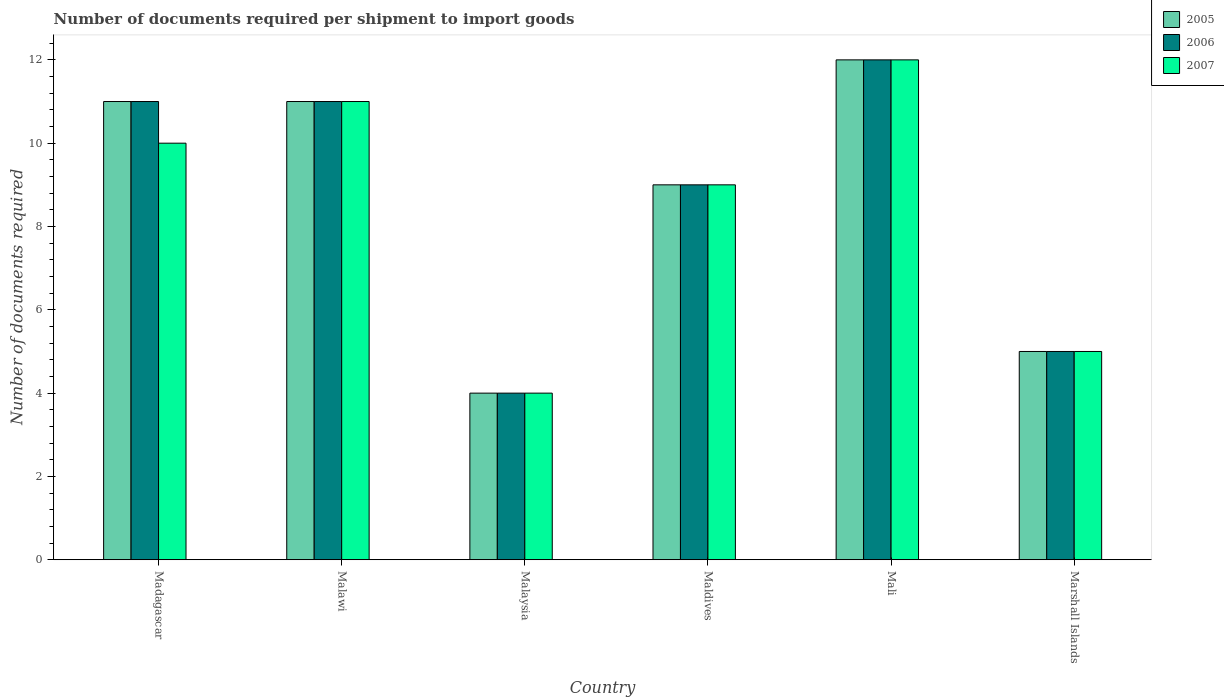How many bars are there on the 3rd tick from the left?
Your answer should be very brief. 3. How many bars are there on the 5th tick from the right?
Give a very brief answer. 3. What is the label of the 4th group of bars from the left?
Offer a very short reply. Maldives. In how many cases, is the number of bars for a given country not equal to the number of legend labels?
Your answer should be very brief. 0. What is the number of documents required per shipment to import goods in 2006 in Maldives?
Make the answer very short. 9. Across all countries, what is the maximum number of documents required per shipment to import goods in 2007?
Ensure brevity in your answer.  12. Across all countries, what is the minimum number of documents required per shipment to import goods in 2007?
Provide a succinct answer. 4. In which country was the number of documents required per shipment to import goods in 2007 maximum?
Provide a succinct answer. Mali. In which country was the number of documents required per shipment to import goods in 2007 minimum?
Your answer should be very brief. Malaysia. What is the total number of documents required per shipment to import goods in 2006 in the graph?
Offer a terse response. 52. What is the difference between the number of documents required per shipment to import goods in 2006 in Marshall Islands and the number of documents required per shipment to import goods in 2007 in Madagascar?
Ensure brevity in your answer.  -5. What is the average number of documents required per shipment to import goods in 2005 per country?
Offer a terse response. 8.67. What is the difference between the number of documents required per shipment to import goods of/in 2007 and number of documents required per shipment to import goods of/in 2005 in Mali?
Offer a very short reply. 0. In how many countries, is the number of documents required per shipment to import goods in 2007 greater than 10?
Keep it short and to the point. 2. What is the ratio of the number of documents required per shipment to import goods in 2006 in Malaysia to that in Maldives?
Give a very brief answer. 0.44. Is the number of documents required per shipment to import goods in 2007 in Malawi less than that in Marshall Islands?
Ensure brevity in your answer.  No. Is the difference between the number of documents required per shipment to import goods in 2007 in Malawi and Malaysia greater than the difference between the number of documents required per shipment to import goods in 2005 in Malawi and Malaysia?
Ensure brevity in your answer.  No. What is the difference between the highest and the second highest number of documents required per shipment to import goods in 2005?
Offer a terse response. -1. In how many countries, is the number of documents required per shipment to import goods in 2006 greater than the average number of documents required per shipment to import goods in 2006 taken over all countries?
Your response must be concise. 4. Is the sum of the number of documents required per shipment to import goods in 2006 in Malaysia and Mali greater than the maximum number of documents required per shipment to import goods in 2007 across all countries?
Make the answer very short. Yes. What does the 1st bar from the right in Mali represents?
Offer a very short reply. 2007. Is it the case that in every country, the sum of the number of documents required per shipment to import goods in 2005 and number of documents required per shipment to import goods in 2006 is greater than the number of documents required per shipment to import goods in 2007?
Make the answer very short. Yes. How many countries are there in the graph?
Your answer should be compact. 6. What is the difference between two consecutive major ticks on the Y-axis?
Provide a short and direct response. 2. Are the values on the major ticks of Y-axis written in scientific E-notation?
Provide a short and direct response. No. Does the graph contain grids?
Offer a very short reply. No. Where does the legend appear in the graph?
Your answer should be very brief. Top right. How are the legend labels stacked?
Ensure brevity in your answer.  Vertical. What is the title of the graph?
Your answer should be compact. Number of documents required per shipment to import goods. What is the label or title of the X-axis?
Provide a short and direct response. Country. What is the label or title of the Y-axis?
Your answer should be very brief. Number of documents required. What is the Number of documents required in 2006 in Madagascar?
Offer a terse response. 11. What is the Number of documents required of 2005 in Malawi?
Offer a terse response. 11. What is the Number of documents required in 2007 in Malawi?
Offer a terse response. 11. What is the Number of documents required in 2006 in Malaysia?
Your answer should be compact. 4. What is the Number of documents required of 2007 in Malaysia?
Give a very brief answer. 4. What is the Number of documents required of 2006 in Maldives?
Provide a short and direct response. 9. What is the Number of documents required in 2007 in Maldives?
Your response must be concise. 9. What is the Number of documents required of 2006 in Mali?
Offer a very short reply. 12. What is the Number of documents required of 2007 in Mali?
Give a very brief answer. 12. What is the Number of documents required in 2005 in Marshall Islands?
Keep it short and to the point. 5. What is the Number of documents required of 2007 in Marshall Islands?
Provide a short and direct response. 5. Across all countries, what is the maximum Number of documents required of 2007?
Ensure brevity in your answer.  12. What is the total Number of documents required of 2006 in the graph?
Provide a succinct answer. 52. What is the total Number of documents required in 2007 in the graph?
Offer a terse response. 51. What is the difference between the Number of documents required in 2007 in Madagascar and that in Malawi?
Keep it short and to the point. -1. What is the difference between the Number of documents required in 2006 in Madagascar and that in Maldives?
Your answer should be very brief. 2. What is the difference between the Number of documents required of 2007 in Madagascar and that in Maldives?
Offer a terse response. 1. What is the difference between the Number of documents required in 2006 in Madagascar and that in Mali?
Give a very brief answer. -1. What is the difference between the Number of documents required in 2005 in Madagascar and that in Marshall Islands?
Keep it short and to the point. 6. What is the difference between the Number of documents required of 2005 in Malawi and that in Malaysia?
Keep it short and to the point. 7. What is the difference between the Number of documents required of 2007 in Malawi and that in Malaysia?
Provide a short and direct response. 7. What is the difference between the Number of documents required in 2006 in Malawi and that in Maldives?
Ensure brevity in your answer.  2. What is the difference between the Number of documents required of 2007 in Malawi and that in Maldives?
Provide a succinct answer. 2. What is the difference between the Number of documents required in 2006 in Malawi and that in Mali?
Offer a terse response. -1. What is the difference between the Number of documents required of 2006 in Malawi and that in Marshall Islands?
Ensure brevity in your answer.  6. What is the difference between the Number of documents required of 2007 in Malawi and that in Marshall Islands?
Keep it short and to the point. 6. What is the difference between the Number of documents required in 2006 in Malaysia and that in Maldives?
Your response must be concise. -5. What is the difference between the Number of documents required in 2005 in Malaysia and that in Mali?
Provide a succinct answer. -8. What is the difference between the Number of documents required in 2007 in Malaysia and that in Mali?
Your answer should be very brief. -8. What is the difference between the Number of documents required of 2006 in Malaysia and that in Marshall Islands?
Make the answer very short. -1. What is the difference between the Number of documents required in 2007 in Malaysia and that in Marshall Islands?
Offer a very short reply. -1. What is the difference between the Number of documents required in 2006 in Maldives and that in Mali?
Ensure brevity in your answer.  -3. What is the difference between the Number of documents required of 2007 in Maldives and that in Marshall Islands?
Your response must be concise. 4. What is the difference between the Number of documents required of 2006 in Mali and that in Marshall Islands?
Give a very brief answer. 7. What is the difference between the Number of documents required in 2007 in Mali and that in Marshall Islands?
Offer a terse response. 7. What is the difference between the Number of documents required of 2005 in Madagascar and the Number of documents required of 2006 in Malawi?
Keep it short and to the point. 0. What is the difference between the Number of documents required of 2005 in Madagascar and the Number of documents required of 2007 in Malaysia?
Offer a terse response. 7. What is the difference between the Number of documents required of 2005 in Madagascar and the Number of documents required of 2006 in Maldives?
Ensure brevity in your answer.  2. What is the difference between the Number of documents required of 2005 in Madagascar and the Number of documents required of 2007 in Maldives?
Keep it short and to the point. 2. What is the difference between the Number of documents required in 2006 in Madagascar and the Number of documents required in 2007 in Maldives?
Provide a succinct answer. 2. What is the difference between the Number of documents required of 2006 in Madagascar and the Number of documents required of 2007 in Mali?
Provide a succinct answer. -1. What is the difference between the Number of documents required of 2005 in Madagascar and the Number of documents required of 2006 in Marshall Islands?
Ensure brevity in your answer.  6. What is the difference between the Number of documents required of 2006 in Madagascar and the Number of documents required of 2007 in Marshall Islands?
Offer a very short reply. 6. What is the difference between the Number of documents required of 2005 in Malawi and the Number of documents required of 2007 in Malaysia?
Your answer should be compact. 7. What is the difference between the Number of documents required in 2006 in Malawi and the Number of documents required in 2007 in Malaysia?
Your answer should be very brief. 7. What is the difference between the Number of documents required in 2005 in Malawi and the Number of documents required in 2006 in Maldives?
Offer a very short reply. 2. What is the difference between the Number of documents required of 2005 in Malawi and the Number of documents required of 2006 in Mali?
Your answer should be compact. -1. What is the difference between the Number of documents required of 2005 in Malawi and the Number of documents required of 2006 in Marshall Islands?
Make the answer very short. 6. What is the difference between the Number of documents required in 2005 in Malawi and the Number of documents required in 2007 in Marshall Islands?
Provide a short and direct response. 6. What is the difference between the Number of documents required in 2006 in Malawi and the Number of documents required in 2007 in Marshall Islands?
Keep it short and to the point. 6. What is the difference between the Number of documents required in 2005 in Malaysia and the Number of documents required in 2007 in Maldives?
Make the answer very short. -5. What is the difference between the Number of documents required of 2005 in Malaysia and the Number of documents required of 2006 in Mali?
Provide a succinct answer. -8. What is the difference between the Number of documents required of 2005 in Malaysia and the Number of documents required of 2007 in Mali?
Offer a terse response. -8. What is the difference between the Number of documents required of 2006 in Malaysia and the Number of documents required of 2007 in Mali?
Ensure brevity in your answer.  -8. What is the difference between the Number of documents required in 2005 in Malaysia and the Number of documents required in 2006 in Marshall Islands?
Offer a terse response. -1. What is the difference between the Number of documents required in 2006 in Malaysia and the Number of documents required in 2007 in Marshall Islands?
Keep it short and to the point. -1. What is the difference between the Number of documents required in 2005 in Maldives and the Number of documents required in 2006 in Mali?
Make the answer very short. -3. What is the difference between the Number of documents required in 2006 in Maldives and the Number of documents required in 2007 in Mali?
Your answer should be compact. -3. What is the difference between the Number of documents required in 2005 in Maldives and the Number of documents required in 2007 in Marshall Islands?
Make the answer very short. 4. What is the difference between the Number of documents required in 2005 in Mali and the Number of documents required in 2006 in Marshall Islands?
Provide a succinct answer. 7. What is the difference between the Number of documents required of 2005 in Mali and the Number of documents required of 2007 in Marshall Islands?
Ensure brevity in your answer.  7. What is the average Number of documents required in 2005 per country?
Keep it short and to the point. 8.67. What is the average Number of documents required in 2006 per country?
Give a very brief answer. 8.67. What is the difference between the Number of documents required of 2005 and Number of documents required of 2006 in Madagascar?
Your answer should be compact. 0. What is the difference between the Number of documents required of 2005 and Number of documents required of 2007 in Madagascar?
Provide a short and direct response. 1. What is the difference between the Number of documents required in 2006 and Number of documents required in 2007 in Madagascar?
Offer a terse response. 1. What is the difference between the Number of documents required of 2006 and Number of documents required of 2007 in Malawi?
Your response must be concise. 0. What is the difference between the Number of documents required in 2005 and Number of documents required in 2006 in Malaysia?
Your answer should be very brief. 0. What is the difference between the Number of documents required of 2006 and Number of documents required of 2007 in Malaysia?
Provide a short and direct response. 0. What is the difference between the Number of documents required of 2005 and Number of documents required of 2006 in Maldives?
Provide a short and direct response. 0. What is the difference between the Number of documents required in 2005 and Number of documents required in 2006 in Mali?
Your answer should be very brief. 0. What is the difference between the Number of documents required of 2005 and Number of documents required of 2007 in Mali?
Provide a short and direct response. 0. What is the difference between the Number of documents required in 2005 and Number of documents required in 2006 in Marshall Islands?
Your response must be concise. 0. What is the difference between the Number of documents required in 2005 and Number of documents required in 2007 in Marshall Islands?
Provide a short and direct response. 0. What is the ratio of the Number of documents required in 2005 in Madagascar to that in Malawi?
Offer a terse response. 1. What is the ratio of the Number of documents required in 2005 in Madagascar to that in Malaysia?
Offer a terse response. 2.75. What is the ratio of the Number of documents required of 2006 in Madagascar to that in Malaysia?
Provide a short and direct response. 2.75. What is the ratio of the Number of documents required of 2005 in Madagascar to that in Maldives?
Give a very brief answer. 1.22. What is the ratio of the Number of documents required in 2006 in Madagascar to that in Maldives?
Make the answer very short. 1.22. What is the ratio of the Number of documents required of 2007 in Madagascar to that in Maldives?
Make the answer very short. 1.11. What is the ratio of the Number of documents required in 2005 in Madagascar to that in Mali?
Keep it short and to the point. 0.92. What is the ratio of the Number of documents required in 2006 in Madagascar to that in Mali?
Provide a succinct answer. 0.92. What is the ratio of the Number of documents required in 2007 in Madagascar to that in Mali?
Your answer should be very brief. 0.83. What is the ratio of the Number of documents required of 2006 in Madagascar to that in Marshall Islands?
Provide a succinct answer. 2.2. What is the ratio of the Number of documents required of 2007 in Madagascar to that in Marshall Islands?
Provide a short and direct response. 2. What is the ratio of the Number of documents required in 2005 in Malawi to that in Malaysia?
Provide a succinct answer. 2.75. What is the ratio of the Number of documents required of 2006 in Malawi to that in Malaysia?
Ensure brevity in your answer.  2.75. What is the ratio of the Number of documents required in 2007 in Malawi to that in Malaysia?
Offer a terse response. 2.75. What is the ratio of the Number of documents required in 2005 in Malawi to that in Maldives?
Provide a succinct answer. 1.22. What is the ratio of the Number of documents required in 2006 in Malawi to that in Maldives?
Your response must be concise. 1.22. What is the ratio of the Number of documents required of 2007 in Malawi to that in Maldives?
Offer a very short reply. 1.22. What is the ratio of the Number of documents required of 2005 in Malawi to that in Mali?
Keep it short and to the point. 0.92. What is the ratio of the Number of documents required of 2005 in Malaysia to that in Maldives?
Offer a very short reply. 0.44. What is the ratio of the Number of documents required of 2006 in Malaysia to that in Maldives?
Provide a short and direct response. 0.44. What is the ratio of the Number of documents required in 2007 in Malaysia to that in Maldives?
Make the answer very short. 0.44. What is the ratio of the Number of documents required in 2005 in Malaysia to that in Mali?
Make the answer very short. 0.33. What is the ratio of the Number of documents required of 2006 in Malaysia to that in Mali?
Your answer should be compact. 0.33. What is the ratio of the Number of documents required of 2005 in Malaysia to that in Marshall Islands?
Give a very brief answer. 0.8. What is the ratio of the Number of documents required in 2007 in Malaysia to that in Marshall Islands?
Make the answer very short. 0.8. What is the ratio of the Number of documents required in 2006 in Maldives to that in Marshall Islands?
Give a very brief answer. 1.8. What is the ratio of the Number of documents required in 2007 in Maldives to that in Marshall Islands?
Offer a very short reply. 1.8. What is the ratio of the Number of documents required in 2005 in Mali to that in Marshall Islands?
Ensure brevity in your answer.  2.4. What is the ratio of the Number of documents required of 2006 in Mali to that in Marshall Islands?
Make the answer very short. 2.4. What is the ratio of the Number of documents required in 2007 in Mali to that in Marshall Islands?
Offer a terse response. 2.4. What is the difference between the highest and the second highest Number of documents required in 2006?
Give a very brief answer. 1. What is the difference between the highest and the second highest Number of documents required in 2007?
Your answer should be compact. 1. What is the difference between the highest and the lowest Number of documents required in 2005?
Your answer should be compact. 8. 